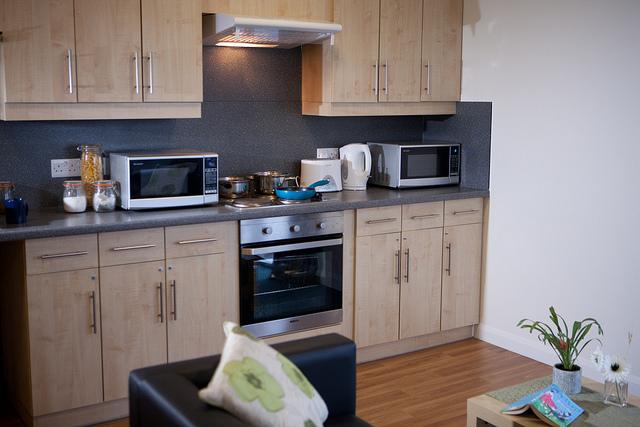What material are the cabinets made from?
Be succinct. Wood. What color is the frying pan?
Concise answer only. Blue. Is there more than one light source for this kitchen?
Be succinct. Yes. 